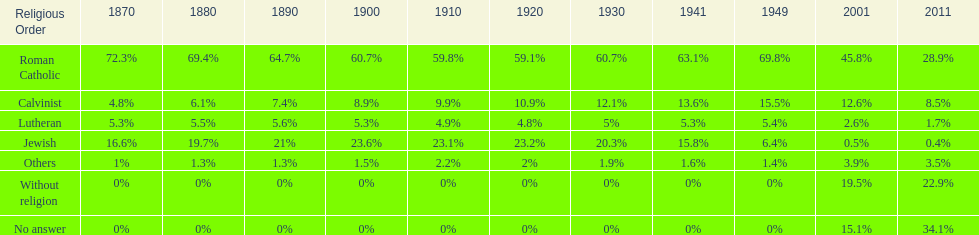Which denomination percentage increased the most after 1949? Without religion. 